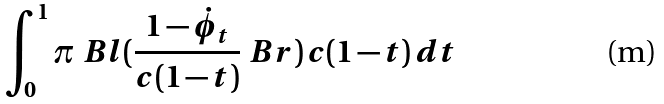<formula> <loc_0><loc_0><loc_500><loc_500>\int _ { 0 } ^ { 1 } \pi \ B l ( \frac { 1 - \dot { \phi } _ { t } } { c ( 1 - t ) } \ B r ) \, c ( 1 - t ) \, d t</formula> 